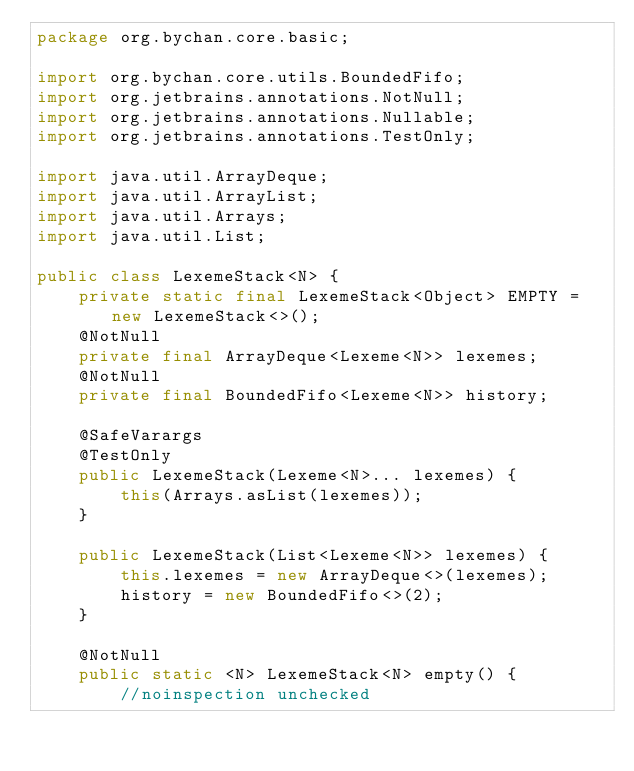Convert code to text. <code><loc_0><loc_0><loc_500><loc_500><_Java_>package org.bychan.core.basic;

import org.bychan.core.utils.BoundedFifo;
import org.jetbrains.annotations.NotNull;
import org.jetbrains.annotations.Nullable;
import org.jetbrains.annotations.TestOnly;

import java.util.ArrayDeque;
import java.util.ArrayList;
import java.util.Arrays;
import java.util.List;

public class LexemeStack<N> {
    private static final LexemeStack<Object> EMPTY = new LexemeStack<>();
    @NotNull
    private final ArrayDeque<Lexeme<N>> lexemes;
    @NotNull
    private final BoundedFifo<Lexeme<N>> history;

    @SafeVarargs
    @TestOnly
    public LexemeStack(Lexeme<N>... lexemes) {
        this(Arrays.asList(lexemes));
    }

    public LexemeStack(List<Lexeme<N>> lexemes) {
        this.lexemes = new ArrayDeque<>(lexemes);
        history = new BoundedFifo<>(2);
    }

    @NotNull
    public static <N> LexemeStack<N> empty() {
        //noinspection unchecked</code> 